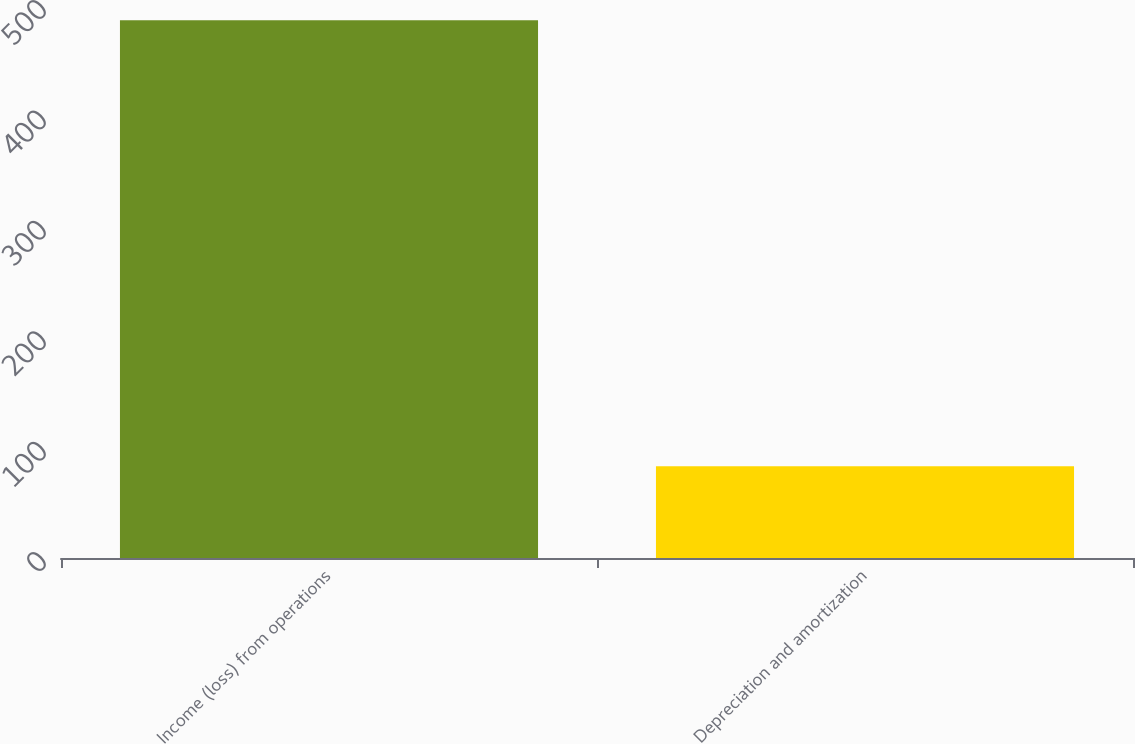Convert chart. <chart><loc_0><loc_0><loc_500><loc_500><bar_chart><fcel>Income (loss) from operations<fcel>Depreciation and amortization<nl><fcel>487<fcel>83.1<nl></chart> 